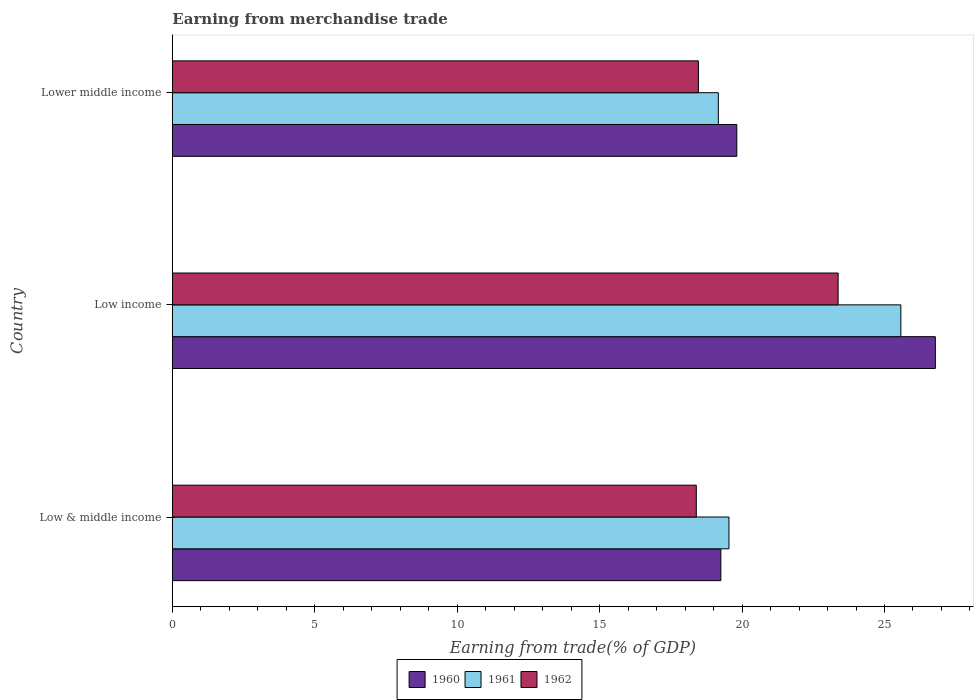How many groups of bars are there?
Offer a terse response. 3. How many bars are there on the 1st tick from the top?
Give a very brief answer. 3. How many bars are there on the 3rd tick from the bottom?
Keep it short and to the point. 3. What is the earnings from trade in 1962 in Low income?
Your response must be concise. 23.37. Across all countries, what is the maximum earnings from trade in 1962?
Ensure brevity in your answer.  23.37. Across all countries, what is the minimum earnings from trade in 1962?
Your answer should be compact. 18.39. In which country was the earnings from trade in 1960 maximum?
Your response must be concise. Low income. What is the total earnings from trade in 1961 in the graph?
Keep it short and to the point. 64.28. What is the difference between the earnings from trade in 1961 in Low income and that in Lower middle income?
Your answer should be compact. 6.41. What is the difference between the earnings from trade in 1962 in Low & middle income and the earnings from trade in 1961 in Low income?
Give a very brief answer. -7.18. What is the average earnings from trade in 1961 per country?
Keep it short and to the point. 21.43. What is the difference between the earnings from trade in 1962 and earnings from trade in 1960 in Low income?
Give a very brief answer. -3.41. In how many countries, is the earnings from trade in 1962 greater than 22 %?
Make the answer very short. 1. What is the ratio of the earnings from trade in 1960 in Low income to that in Lower middle income?
Keep it short and to the point. 1.35. Is the earnings from trade in 1961 in Low income less than that in Lower middle income?
Your answer should be compact. No. What is the difference between the highest and the second highest earnings from trade in 1960?
Make the answer very short. 6.97. What is the difference between the highest and the lowest earnings from trade in 1960?
Your answer should be very brief. 7.53. In how many countries, is the earnings from trade in 1961 greater than the average earnings from trade in 1961 taken over all countries?
Offer a terse response. 1. What does the 1st bar from the bottom in Low income represents?
Offer a very short reply. 1960. Is it the case that in every country, the sum of the earnings from trade in 1960 and earnings from trade in 1961 is greater than the earnings from trade in 1962?
Your answer should be compact. Yes. How many bars are there?
Your answer should be very brief. 9. Are all the bars in the graph horizontal?
Ensure brevity in your answer.  Yes. How many countries are there in the graph?
Make the answer very short. 3. What is the difference between two consecutive major ticks on the X-axis?
Your response must be concise. 5. Are the values on the major ticks of X-axis written in scientific E-notation?
Make the answer very short. No. Does the graph contain grids?
Provide a short and direct response. No. What is the title of the graph?
Make the answer very short. Earning from merchandise trade. Does "1991" appear as one of the legend labels in the graph?
Ensure brevity in your answer.  No. What is the label or title of the X-axis?
Your answer should be compact. Earning from trade(% of GDP). What is the label or title of the Y-axis?
Keep it short and to the point. Country. What is the Earning from trade(% of GDP) of 1960 in Low & middle income?
Make the answer very short. 19.26. What is the Earning from trade(% of GDP) in 1961 in Low & middle income?
Your response must be concise. 19.54. What is the Earning from trade(% of GDP) in 1962 in Low & middle income?
Your response must be concise. 18.39. What is the Earning from trade(% of GDP) in 1960 in Low income?
Your answer should be very brief. 26.79. What is the Earning from trade(% of GDP) in 1961 in Low income?
Your answer should be compact. 25.57. What is the Earning from trade(% of GDP) of 1962 in Low income?
Offer a very short reply. 23.37. What is the Earning from trade(% of GDP) of 1960 in Lower middle income?
Provide a short and direct response. 19.81. What is the Earning from trade(% of GDP) of 1961 in Lower middle income?
Make the answer very short. 19.17. What is the Earning from trade(% of GDP) of 1962 in Lower middle income?
Provide a short and direct response. 18.47. Across all countries, what is the maximum Earning from trade(% of GDP) in 1960?
Make the answer very short. 26.79. Across all countries, what is the maximum Earning from trade(% of GDP) of 1961?
Provide a short and direct response. 25.57. Across all countries, what is the maximum Earning from trade(% of GDP) of 1962?
Offer a terse response. 23.37. Across all countries, what is the minimum Earning from trade(% of GDP) in 1960?
Offer a terse response. 19.26. Across all countries, what is the minimum Earning from trade(% of GDP) of 1961?
Ensure brevity in your answer.  19.17. Across all countries, what is the minimum Earning from trade(% of GDP) of 1962?
Provide a succinct answer. 18.39. What is the total Earning from trade(% of GDP) in 1960 in the graph?
Your answer should be compact. 65.86. What is the total Earning from trade(% of GDP) of 1961 in the graph?
Offer a very short reply. 64.28. What is the total Earning from trade(% of GDP) in 1962 in the graph?
Give a very brief answer. 60.23. What is the difference between the Earning from trade(% of GDP) of 1960 in Low & middle income and that in Low income?
Keep it short and to the point. -7.53. What is the difference between the Earning from trade(% of GDP) of 1961 in Low & middle income and that in Low income?
Offer a terse response. -6.03. What is the difference between the Earning from trade(% of GDP) of 1962 in Low & middle income and that in Low income?
Provide a succinct answer. -4.98. What is the difference between the Earning from trade(% of GDP) in 1960 in Low & middle income and that in Lower middle income?
Keep it short and to the point. -0.56. What is the difference between the Earning from trade(% of GDP) of 1961 in Low & middle income and that in Lower middle income?
Your answer should be compact. 0.37. What is the difference between the Earning from trade(% of GDP) of 1962 in Low & middle income and that in Lower middle income?
Offer a terse response. -0.07. What is the difference between the Earning from trade(% of GDP) of 1960 in Low income and that in Lower middle income?
Keep it short and to the point. 6.97. What is the difference between the Earning from trade(% of GDP) in 1961 in Low income and that in Lower middle income?
Provide a short and direct response. 6.41. What is the difference between the Earning from trade(% of GDP) of 1962 in Low income and that in Lower middle income?
Give a very brief answer. 4.9. What is the difference between the Earning from trade(% of GDP) of 1960 in Low & middle income and the Earning from trade(% of GDP) of 1961 in Low income?
Your answer should be very brief. -6.32. What is the difference between the Earning from trade(% of GDP) in 1960 in Low & middle income and the Earning from trade(% of GDP) in 1962 in Low income?
Your response must be concise. -4.12. What is the difference between the Earning from trade(% of GDP) in 1961 in Low & middle income and the Earning from trade(% of GDP) in 1962 in Low income?
Your answer should be very brief. -3.83. What is the difference between the Earning from trade(% of GDP) in 1960 in Low & middle income and the Earning from trade(% of GDP) in 1961 in Lower middle income?
Your response must be concise. 0.09. What is the difference between the Earning from trade(% of GDP) of 1960 in Low & middle income and the Earning from trade(% of GDP) of 1962 in Lower middle income?
Make the answer very short. 0.79. What is the difference between the Earning from trade(% of GDP) of 1961 in Low & middle income and the Earning from trade(% of GDP) of 1962 in Lower middle income?
Offer a terse response. 1.07. What is the difference between the Earning from trade(% of GDP) of 1960 in Low income and the Earning from trade(% of GDP) of 1961 in Lower middle income?
Provide a short and direct response. 7.62. What is the difference between the Earning from trade(% of GDP) in 1960 in Low income and the Earning from trade(% of GDP) in 1962 in Lower middle income?
Your response must be concise. 8.32. What is the difference between the Earning from trade(% of GDP) of 1961 in Low income and the Earning from trade(% of GDP) of 1962 in Lower middle income?
Provide a succinct answer. 7.11. What is the average Earning from trade(% of GDP) of 1960 per country?
Your response must be concise. 21.95. What is the average Earning from trade(% of GDP) in 1961 per country?
Ensure brevity in your answer.  21.43. What is the average Earning from trade(% of GDP) of 1962 per country?
Offer a very short reply. 20.08. What is the difference between the Earning from trade(% of GDP) in 1960 and Earning from trade(% of GDP) in 1961 in Low & middle income?
Your answer should be very brief. -0.29. What is the difference between the Earning from trade(% of GDP) in 1960 and Earning from trade(% of GDP) in 1962 in Low & middle income?
Provide a short and direct response. 0.86. What is the difference between the Earning from trade(% of GDP) of 1961 and Earning from trade(% of GDP) of 1962 in Low & middle income?
Provide a succinct answer. 1.15. What is the difference between the Earning from trade(% of GDP) in 1960 and Earning from trade(% of GDP) in 1961 in Low income?
Your response must be concise. 1.21. What is the difference between the Earning from trade(% of GDP) in 1960 and Earning from trade(% of GDP) in 1962 in Low income?
Keep it short and to the point. 3.41. What is the difference between the Earning from trade(% of GDP) of 1961 and Earning from trade(% of GDP) of 1962 in Low income?
Keep it short and to the point. 2.2. What is the difference between the Earning from trade(% of GDP) of 1960 and Earning from trade(% of GDP) of 1961 in Lower middle income?
Give a very brief answer. 0.65. What is the difference between the Earning from trade(% of GDP) in 1960 and Earning from trade(% of GDP) in 1962 in Lower middle income?
Your response must be concise. 1.35. What is the difference between the Earning from trade(% of GDP) in 1961 and Earning from trade(% of GDP) in 1962 in Lower middle income?
Provide a short and direct response. 0.7. What is the ratio of the Earning from trade(% of GDP) in 1960 in Low & middle income to that in Low income?
Give a very brief answer. 0.72. What is the ratio of the Earning from trade(% of GDP) of 1961 in Low & middle income to that in Low income?
Make the answer very short. 0.76. What is the ratio of the Earning from trade(% of GDP) of 1962 in Low & middle income to that in Low income?
Offer a terse response. 0.79. What is the ratio of the Earning from trade(% of GDP) of 1960 in Low & middle income to that in Lower middle income?
Offer a very short reply. 0.97. What is the ratio of the Earning from trade(% of GDP) of 1961 in Low & middle income to that in Lower middle income?
Provide a short and direct response. 1.02. What is the ratio of the Earning from trade(% of GDP) of 1960 in Low income to that in Lower middle income?
Make the answer very short. 1.35. What is the ratio of the Earning from trade(% of GDP) in 1961 in Low income to that in Lower middle income?
Your answer should be very brief. 1.33. What is the ratio of the Earning from trade(% of GDP) in 1962 in Low income to that in Lower middle income?
Offer a very short reply. 1.27. What is the difference between the highest and the second highest Earning from trade(% of GDP) of 1960?
Provide a short and direct response. 6.97. What is the difference between the highest and the second highest Earning from trade(% of GDP) of 1961?
Your answer should be compact. 6.03. What is the difference between the highest and the second highest Earning from trade(% of GDP) of 1962?
Provide a short and direct response. 4.9. What is the difference between the highest and the lowest Earning from trade(% of GDP) of 1960?
Give a very brief answer. 7.53. What is the difference between the highest and the lowest Earning from trade(% of GDP) in 1961?
Make the answer very short. 6.41. What is the difference between the highest and the lowest Earning from trade(% of GDP) in 1962?
Your answer should be very brief. 4.98. 